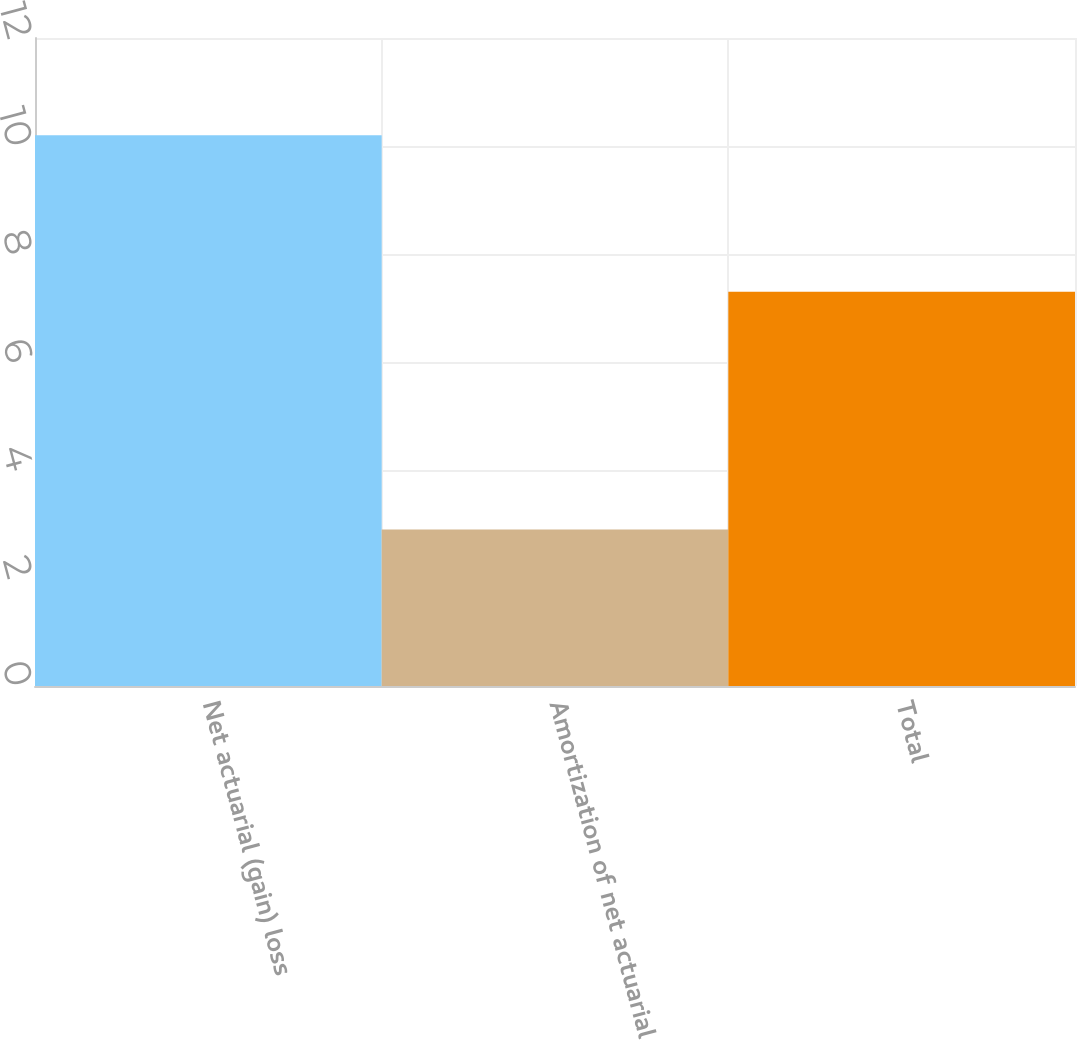Convert chart. <chart><loc_0><loc_0><loc_500><loc_500><bar_chart><fcel>Net actuarial (gain) loss<fcel>Amortization of net actuarial<fcel>Total<nl><fcel>10.2<fcel>2.9<fcel>7.3<nl></chart> 